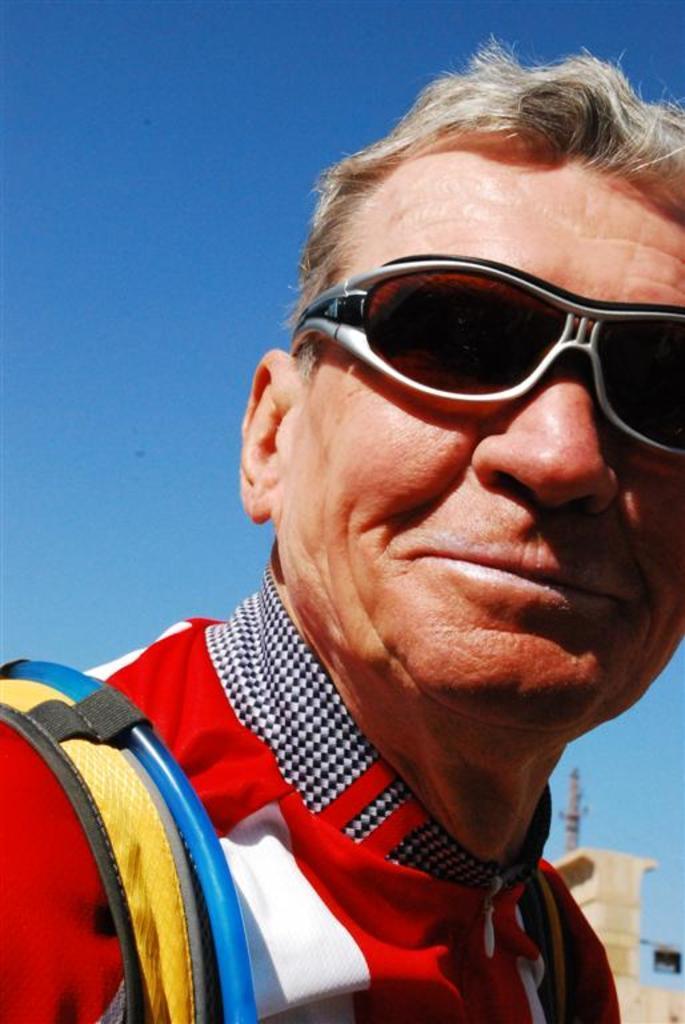How would you summarize this image in a sentence or two? Here we can see a man and he wore goggles to his eyes and carrying a bag on his shoulders. In the background we can see a pole,wall and sky. 